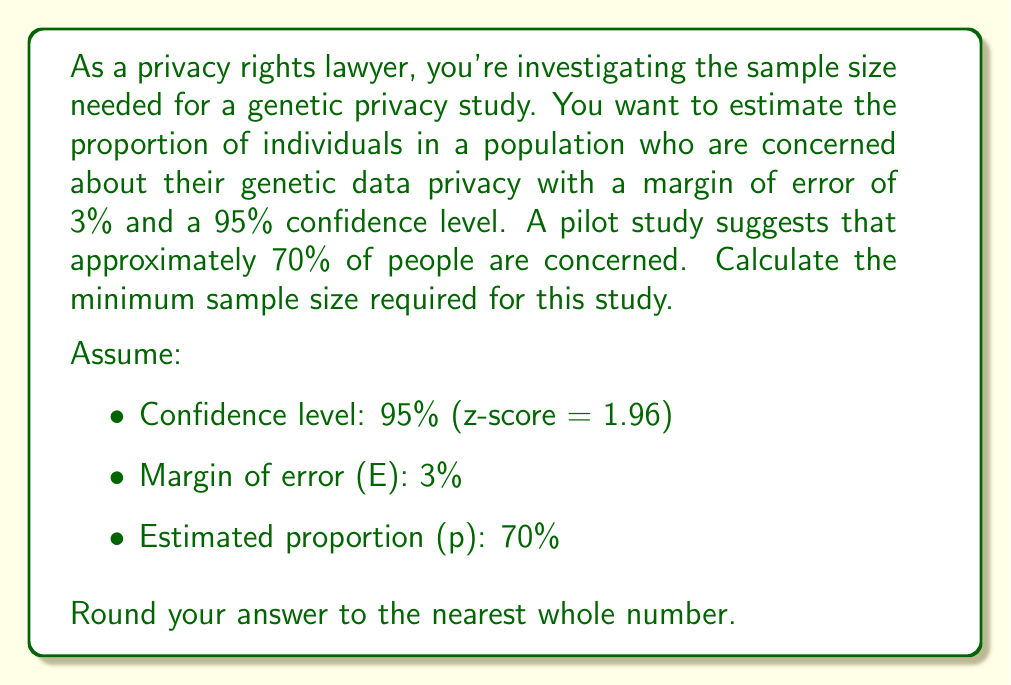Help me with this question. To calculate the required sample size, we'll use the formula for estimating a population proportion:

$$ n = \frac{z^2 p(1-p)}{E^2} $$

Where:
- $n$ is the sample size
- $z$ is the z-score for the desired confidence level
- $p$ is the estimated proportion
- $E$ is the margin of error

Step 1: Identify the values
- $z = 1.96$ (for 95% confidence level)
- $p = 0.70$ (70% expressed as a decimal)
- $E = 0.03$ (3% expressed as a decimal)

Step 2: Plug the values into the formula
$$ n = \frac{1.96^2 \times 0.70(1-0.70)}{0.03^2} $$

Step 3: Solve the equation
$$ n = \frac{3.8416 \times 0.70 \times 0.30}{0.0009} $$
$$ n = \frac{0.80673600}{0.0009} $$
$$ n = 896.3733333... $$

Step 4: Round up to the nearest whole number
$n = 897$

Therefore, the minimum sample size required for this genetic privacy study is 897 individuals.
Answer: 897 